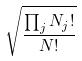Convert formula to latex. <formula><loc_0><loc_0><loc_500><loc_500>\sqrt { \frac { \prod _ { j } N _ { j } ! } { N ! } }</formula> 